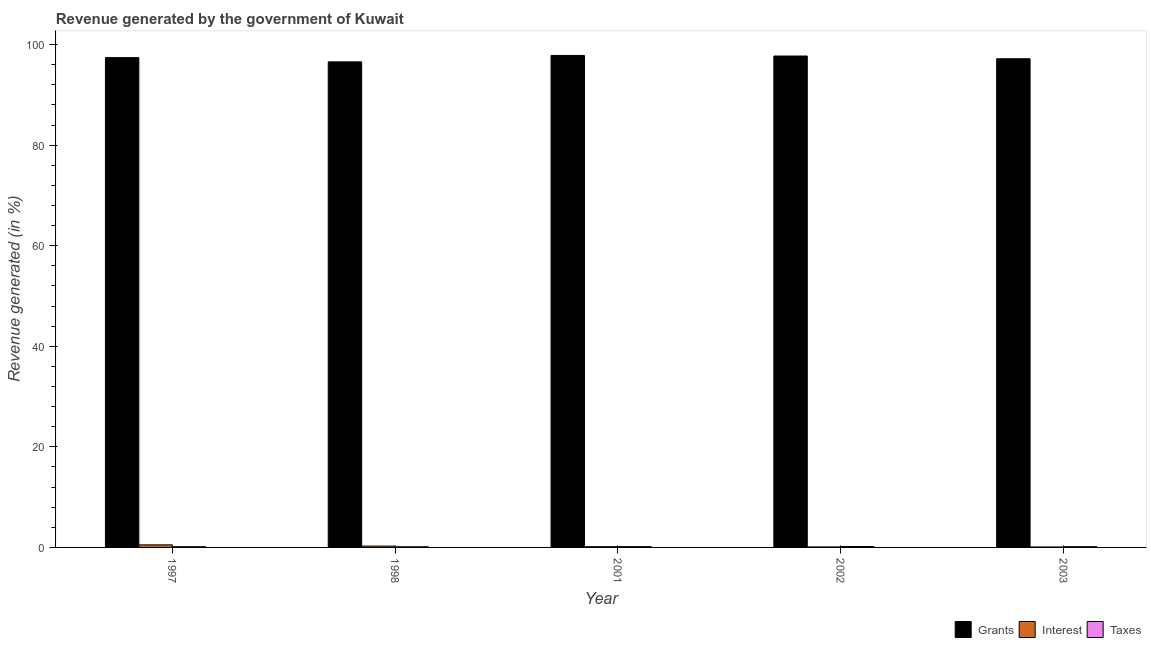How many different coloured bars are there?
Your response must be concise. 3. How many groups of bars are there?
Your answer should be compact. 5. How many bars are there on the 1st tick from the left?
Your answer should be compact. 3. What is the label of the 3rd group of bars from the left?
Provide a short and direct response. 2001. What is the percentage of revenue generated by interest in 2002?
Provide a succinct answer. 0.1. Across all years, what is the maximum percentage of revenue generated by taxes?
Provide a succinct answer. 0.18. Across all years, what is the minimum percentage of revenue generated by interest?
Ensure brevity in your answer.  0.08. In which year was the percentage of revenue generated by grants maximum?
Provide a succinct answer. 2001. In which year was the percentage of revenue generated by interest minimum?
Ensure brevity in your answer.  2003. What is the total percentage of revenue generated by grants in the graph?
Offer a very short reply. 486.75. What is the difference between the percentage of revenue generated by interest in 1998 and that in 2001?
Ensure brevity in your answer.  0.12. What is the difference between the percentage of revenue generated by grants in 2003 and the percentage of revenue generated by interest in 2002?
Make the answer very short. -0.54. What is the average percentage of revenue generated by grants per year?
Offer a terse response. 97.35. In the year 1997, what is the difference between the percentage of revenue generated by grants and percentage of revenue generated by interest?
Make the answer very short. 0. What is the ratio of the percentage of revenue generated by taxes in 2001 to that in 2002?
Your response must be concise. 0.93. Is the difference between the percentage of revenue generated by grants in 1997 and 2003 greater than the difference between the percentage of revenue generated by interest in 1997 and 2003?
Provide a short and direct response. No. What is the difference between the highest and the second highest percentage of revenue generated by interest?
Your answer should be compact. 0.25. What is the difference between the highest and the lowest percentage of revenue generated by taxes?
Provide a short and direct response. 0.04. In how many years, is the percentage of revenue generated by grants greater than the average percentage of revenue generated by grants taken over all years?
Keep it short and to the point. 3. Is the sum of the percentage of revenue generated by interest in 1997 and 2001 greater than the maximum percentage of revenue generated by taxes across all years?
Ensure brevity in your answer.  Yes. What does the 1st bar from the left in 1998 represents?
Your answer should be compact. Grants. What does the 1st bar from the right in 2002 represents?
Your answer should be compact. Taxes. How many years are there in the graph?
Your answer should be very brief. 5. Does the graph contain any zero values?
Your answer should be compact. No. Where does the legend appear in the graph?
Make the answer very short. Bottom right. How are the legend labels stacked?
Your response must be concise. Horizontal. What is the title of the graph?
Provide a succinct answer. Revenue generated by the government of Kuwait. What is the label or title of the Y-axis?
Provide a succinct answer. Revenue generated (in %). What is the Revenue generated (in %) in Grants in 1997?
Keep it short and to the point. 97.41. What is the Revenue generated (in %) of Interest in 1997?
Your answer should be compact. 0.51. What is the Revenue generated (in %) in Taxes in 1997?
Make the answer very short. 0.15. What is the Revenue generated (in %) of Grants in 1998?
Provide a short and direct response. 96.57. What is the Revenue generated (in %) in Interest in 1998?
Give a very brief answer. 0.27. What is the Revenue generated (in %) of Taxes in 1998?
Make the answer very short. 0.14. What is the Revenue generated (in %) in Grants in 2001?
Your response must be concise. 97.85. What is the Revenue generated (in %) of Interest in 2001?
Offer a very short reply. 0.15. What is the Revenue generated (in %) of Taxes in 2001?
Offer a very short reply. 0.17. What is the Revenue generated (in %) in Grants in 2002?
Ensure brevity in your answer.  97.73. What is the Revenue generated (in %) in Interest in 2002?
Ensure brevity in your answer.  0.1. What is the Revenue generated (in %) in Taxes in 2002?
Offer a terse response. 0.18. What is the Revenue generated (in %) of Grants in 2003?
Offer a terse response. 97.19. What is the Revenue generated (in %) in Interest in 2003?
Your answer should be compact. 0.08. What is the Revenue generated (in %) of Taxes in 2003?
Your response must be concise. 0.15. Across all years, what is the maximum Revenue generated (in %) of Grants?
Provide a succinct answer. 97.85. Across all years, what is the maximum Revenue generated (in %) of Interest?
Ensure brevity in your answer.  0.51. Across all years, what is the maximum Revenue generated (in %) of Taxes?
Make the answer very short. 0.18. Across all years, what is the minimum Revenue generated (in %) in Grants?
Make the answer very short. 96.57. Across all years, what is the minimum Revenue generated (in %) in Interest?
Provide a succinct answer. 0.08. Across all years, what is the minimum Revenue generated (in %) of Taxes?
Give a very brief answer. 0.14. What is the total Revenue generated (in %) in Grants in the graph?
Provide a short and direct response. 486.75. What is the total Revenue generated (in %) in Interest in the graph?
Give a very brief answer. 1.11. What is the total Revenue generated (in %) of Taxes in the graph?
Make the answer very short. 0.77. What is the difference between the Revenue generated (in %) of Grants in 1997 and that in 1998?
Offer a terse response. 0.84. What is the difference between the Revenue generated (in %) in Interest in 1997 and that in 1998?
Provide a short and direct response. 0.25. What is the difference between the Revenue generated (in %) in Taxes in 1997 and that in 1998?
Your response must be concise. 0.01. What is the difference between the Revenue generated (in %) in Grants in 1997 and that in 2001?
Your answer should be very brief. -0.44. What is the difference between the Revenue generated (in %) in Interest in 1997 and that in 2001?
Keep it short and to the point. 0.36. What is the difference between the Revenue generated (in %) in Taxes in 1997 and that in 2001?
Keep it short and to the point. -0.02. What is the difference between the Revenue generated (in %) in Grants in 1997 and that in 2002?
Keep it short and to the point. -0.32. What is the difference between the Revenue generated (in %) of Interest in 1997 and that in 2002?
Provide a succinct answer. 0.42. What is the difference between the Revenue generated (in %) of Taxes in 1997 and that in 2002?
Your answer should be very brief. -0.03. What is the difference between the Revenue generated (in %) of Grants in 1997 and that in 2003?
Ensure brevity in your answer.  0.22. What is the difference between the Revenue generated (in %) of Interest in 1997 and that in 2003?
Your answer should be very brief. 0.43. What is the difference between the Revenue generated (in %) in Taxes in 1997 and that in 2003?
Provide a succinct answer. -0. What is the difference between the Revenue generated (in %) in Grants in 1998 and that in 2001?
Give a very brief answer. -1.28. What is the difference between the Revenue generated (in %) of Interest in 1998 and that in 2001?
Your answer should be compact. 0.12. What is the difference between the Revenue generated (in %) of Taxes in 1998 and that in 2001?
Give a very brief answer. -0.03. What is the difference between the Revenue generated (in %) in Grants in 1998 and that in 2002?
Your answer should be very brief. -1.16. What is the difference between the Revenue generated (in %) in Interest in 1998 and that in 2002?
Make the answer very short. 0.17. What is the difference between the Revenue generated (in %) of Taxes in 1998 and that in 2002?
Offer a terse response. -0.04. What is the difference between the Revenue generated (in %) in Grants in 1998 and that in 2003?
Keep it short and to the point. -0.62. What is the difference between the Revenue generated (in %) in Interest in 1998 and that in 2003?
Give a very brief answer. 0.18. What is the difference between the Revenue generated (in %) in Taxes in 1998 and that in 2003?
Provide a succinct answer. -0.01. What is the difference between the Revenue generated (in %) of Grants in 2001 and that in 2002?
Give a very brief answer. 0.12. What is the difference between the Revenue generated (in %) in Interest in 2001 and that in 2002?
Make the answer very short. 0.05. What is the difference between the Revenue generated (in %) of Taxes in 2001 and that in 2002?
Keep it short and to the point. -0.01. What is the difference between the Revenue generated (in %) of Grants in 2001 and that in 2003?
Offer a terse response. 0.66. What is the difference between the Revenue generated (in %) in Interest in 2001 and that in 2003?
Your answer should be compact. 0.06. What is the difference between the Revenue generated (in %) of Taxes in 2001 and that in 2003?
Make the answer very short. 0.02. What is the difference between the Revenue generated (in %) in Grants in 2002 and that in 2003?
Your answer should be very brief. 0.54. What is the difference between the Revenue generated (in %) in Interest in 2002 and that in 2003?
Make the answer very short. 0.01. What is the difference between the Revenue generated (in %) of Taxes in 2002 and that in 2003?
Your answer should be very brief. 0.03. What is the difference between the Revenue generated (in %) of Grants in 1997 and the Revenue generated (in %) of Interest in 1998?
Offer a terse response. 97.14. What is the difference between the Revenue generated (in %) of Grants in 1997 and the Revenue generated (in %) of Taxes in 1998?
Make the answer very short. 97.27. What is the difference between the Revenue generated (in %) of Interest in 1997 and the Revenue generated (in %) of Taxes in 1998?
Keep it short and to the point. 0.38. What is the difference between the Revenue generated (in %) in Grants in 1997 and the Revenue generated (in %) in Interest in 2001?
Provide a short and direct response. 97.26. What is the difference between the Revenue generated (in %) of Grants in 1997 and the Revenue generated (in %) of Taxes in 2001?
Offer a very short reply. 97.24. What is the difference between the Revenue generated (in %) in Interest in 1997 and the Revenue generated (in %) in Taxes in 2001?
Offer a very short reply. 0.35. What is the difference between the Revenue generated (in %) in Grants in 1997 and the Revenue generated (in %) in Interest in 2002?
Offer a very short reply. 97.31. What is the difference between the Revenue generated (in %) of Grants in 1997 and the Revenue generated (in %) of Taxes in 2002?
Provide a short and direct response. 97.23. What is the difference between the Revenue generated (in %) of Interest in 1997 and the Revenue generated (in %) of Taxes in 2002?
Provide a short and direct response. 0.33. What is the difference between the Revenue generated (in %) of Grants in 1997 and the Revenue generated (in %) of Interest in 2003?
Provide a succinct answer. 97.32. What is the difference between the Revenue generated (in %) in Grants in 1997 and the Revenue generated (in %) in Taxes in 2003?
Provide a succinct answer. 97.26. What is the difference between the Revenue generated (in %) of Interest in 1997 and the Revenue generated (in %) of Taxes in 2003?
Ensure brevity in your answer.  0.36. What is the difference between the Revenue generated (in %) of Grants in 1998 and the Revenue generated (in %) of Interest in 2001?
Ensure brevity in your answer.  96.42. What is the difference between the Revenue generated (in %) in Grants in 1998 and the Revenue generated (in %) in Taxes in 2001?
Your answer should be very brief. 96.4. What is the difference between the Revenue generated (in %) of Interest in 1998 and the Revenue generated (in %) of Taxes in 2001?
Make the answer very short. 0.1. What is the difference between the Revenue generated (in %) of Grants in 1998 and the Revenue generated (in %) of Interest in 2002?
Make the answer very short. 96.47. What is the difference between the Revenue generated (in %) of Grants in 1998 and the Revenue generated (in %) of Taxes in 2002?
Keep it short and to the point. 96.39. What is the difference between the Revenue generated (in %) in Interest in 1998 and the Revenue generated (in %) in Taxes in 2002?
Offer a very short reply. 0.09. What is the difference between the Revenue generated (in %) of Grants in 1998 and the Revenue generated (in %) of Interest in 2003?
Your response must be concise. 96.48. What is the difference between the Revenue generated (in %) in Grants in 1998 and the Revenue generated (in %) in Taxes in 2003?
Make the answer very short. 96.42. What is the difference between the Revenue generated (in %) of Interest in 1998 and the Revenue generated (in %) of Taxes in 2003?
Give a very brief answer. 0.12. What is the difference between the Revenue generated (in %) in Grants in 2001 and the Revenue generated (in %) in Interest in 2002?
Give a very brief answer. 97.75. What is the difference between the Revenue generated (in %) in Grants in 2001 and the Revenue generated (in %) in Taxes in 2002?
Make the answer very short. 97.67. What is the difference between the Revenue generated (in %) of Interest in 2001 and the Revenue generated (in %) of Taxes in 2002?
Offer a very short reply. -0.03. What is the difference between the Revenue generated (in %) in Grants in 2001 and the Revenue generated (in %) in Interest in 2003?
Offer a terse response. 97.77. What is the difference between the Revenue generated (in %) of Grants in 2001 and the Revenue generated (in %) of Taxes in 2003?
Provide a short and direct response. 97.7. What is the difference between the Revenue generated (in %) in Interest in 2001 and the Revenue generated (in %) in Taxes in 2003?
Provide a short and direct response. 0. What is the difference between the Revenue generated (in %) in Grants in 2002 and the Revenue generated (in %) in Interest in 2003?
Your response must be concise. 97.65. What is the difference between the Revenue generated (in %) of Grants in 2002 and the Revenue generated (in %) of Taxes in 2003?
Provide a short and direct response. 97.58. What is the difference between the Revenue generated (in %) of Interest in 2002 and the Revenue generated (in %) of Taxes in 2003?
Make the answer very short. -0.05. What is the average Revenue generated (in %) in Grants per year?
Offer a terse response. 97.35. What is the average Revenue generated (in %) of Interest per year?
Offer a very short reply. 0.22. What is the average Revenue generated (in %) of Taxes per year?
Make the answer very short. 0.15. In the year 1997, what is the difference between the Revenue generated (in %) of Grants and Revenue generated (in %) of Interest?
Your response must be concise. 96.9. In the year 1997, what is the difference between the Revenue generated (in %) of Grants and Revenue generated (in %) of Taxes?
Offer a very short reply. 97.26. In the year 1997, what is the difference between the Revenue generated (in %) of Interest and Revenue generated (in %) of Taxes?
Provide a short and direct response. 0.37. In the year 1998, what is the difference between the Revenue generated (in %) of Grants and Revenue generated (in %) of Interest?
Provide a short and direct response. 96.3. In the year 1998, what is the difference between the Revenue generated (in %) of Grants and Revenue generated (in %) of Taxes?
Your answer should be very brief. 96.43. In the year 1998, what is the difference between the Revenue generated (in %) in Interest and Revenue generated (in %) in Taxes?
Keep it short and to the point. 0.13. In the year 2001, what is the difference between the Revenue generated (in %) of Grants and Revenue generated (in %) of Interest?
Offer a terse response. 97.7. In the year 2001, what is the difference between the Revenue generated (in %) in Grants and Revenue generated (in %) in Taxes?
Make the answer very short. 97.68. In the year 2001, what is the difference between the Revenue generated (in %) in Interest and Revenue generated (in %) in Taxes?
Offer a very short reply. -0.02. In the year 2002, what is the difference between the Revenue generated (in %) in Grants and Revenue generated (in %) in Interest?
Offer a very short reply. 97.64. In the year 2002, what is the difference between the Revenue generated (in %) in Grants and Revenue generated (in %) in Taxes?
Keep it short and to the point. 97.55. In the year 2002, what is the difference between the Revenue generated (in %) of Interest and Revenue generated (in %) of Taxes?
Your response must be concise. -0.08. In the year 2003, what is the difference between the Revenue generated (in %) in Grants and Revenue generated (in %) in Interest?
Your response must be concise. 97.1. In the year 2003, what is the difference between the Revenue generated (in %) in Grants and Revenue generated (in %) in Taxes?
Give a very brief answer. 97.04. In the year 2003, what is the difference between the Revenue generated (in %) of Interest and Revenue generated (in %) of Taxes?
Offer a very short reply. -0.06. What is the ratio of the Revenue generated (in %) of Grants in 1997 to that in 1998?
Provide a short and direct response. 1.01. What is the ratio of the Revenue generated (in %) of Interest in 1997 to that in 1998?
Give a very brief answer. 1.92. What is the ratio of the Revenue generated (in %) of Taxes in 1997 to that in 1998?
Provide a succinct answer. 1.07. What is the ratio of the Revenue generated (in %) of Grants in 1997 to that in 2001?
Offer a terse response. 1. What is the ratio of the Revenue generated (in %) of Interest in 1997 to that in 2001?
Keep it short and to the point. 3.45. What is the ratio of the Revenue generated (in %) of Taxes in 1997 to that in 2001?
Provide a short and direct response. 0.88. What is the ratio of the Revenue generated (in %) of Grants in 1997 to that in 2002?
Provide a succinct answer. 1. What is the ratio of the Revenue generated (in %) in Interest in 1997 to that in 2002?
Your response must be concise. 5.35. What is the ratio of the Revenue generated (in %) of Taxes in 1997 to that in 2002?
Your answer should be compact. 0.81. What is the ratio of the Revenue generated (in %) of Interest in 1997 to that in 2003?
Your response must be concise. 6.04. What is the ratio of the Revenue generated (in %) in Taxes in 1997 to that in 2003?
Keep it short and to the point. 0.98. What is the ratio of the Revenue generated (in %) of Grants in 1998 to that in 2001?
Ensure brevity in your answer.  0.99. What is the ratio of the Revenue generated (in %) in Interest in 1998 to that in 2001?
Offer a terse response. 1.8. What is the ratio of the Revenue generated (in %) of Taxes in 1998 to that in 2001?
Your response must be concise. 0.82. What is the ratio of the Revenue generated (in %) of Grants in 1998 to that in 2002?
Your answer should be very brief. 0.99. What is the ratio of the Revenue generated (in %) of Interest in 1998 to that in 2002?
Make the answer very short. 2.79. What is the ratio of the Revenue generated (in %) in Taxes in 1998 to that in 2002?
Keep it short and to the point. 0.76. What is the ratio of the Revenue generated (in %) in Grants in 1998 to that in 2003?
Ensure brevity in your answer.  0.99. What is the ratio of the Revenue generated (in %) of Interest in 1998 to that in 2003?
Make the answer very short. 3.15. What is the ratio of the Revenue generated (in %) in Taxes in 1998 to that in 2003?
Provide a short and direct response. 0.91. What is the ratio of the Revenue generated (in %) of Grants in 2001 to that in 2002?
Ensure brevity in your answer.  1. What is the ratio of the Revenue generated (in %) of Interest in 2001 to that in 2002?
Your response must be concise. 1.55. What is the ratio of the Revenue generated (in %) in Taxes in 2001 to that in 2002?
Keep it short and to the point. 0.93. What is the ratio of the Revenue generated (in %) in Grants in 2001 to that in 2003?
Offer a very short reply. 1.01. What is the ratio of the Revenue generated (in %) of Interest in 2001 to that in 2003?
Make the answer very short. 1.75. What is the ratio of the Revenue generated (in %) in Taxes in 2001 to that in 2003?
Provide a short and direct response. 1.11. What is the ratio of the Revenue generated (in %) of Grants in 2002 to that in 2003?
Provide a short and direct response. 1.01. What is the ratio of the Revenue generated (in %) in Interest in 2002 to that in 2003?
Your answer should be very brief. 1.13. What is the difference between the highest and the second highest Revenue generated (in %) in Grants?
Provide a short and direct response. 0.12. What is the difference between the highest and the second highest Revenue generated (in %) in Interest?
Your answer should be very brief. 0.25. What is the difference between the highest and the second highest Revenue generated (in %) in Taxes?
Offer a very short reply. 0.01. What is the difference between the highest and the lowest Revenue generated (in %) in Grants?
Ensure brevity in your answer.  1.28. What is the difference between the highest and the lowest Revenue generated (in %) of Interest?
Your response must be concise. 0.43. What is the difference between the highest and the lowest Revenue generated (in %) of Taxes?
Keep it short and to the point. 0.04. 